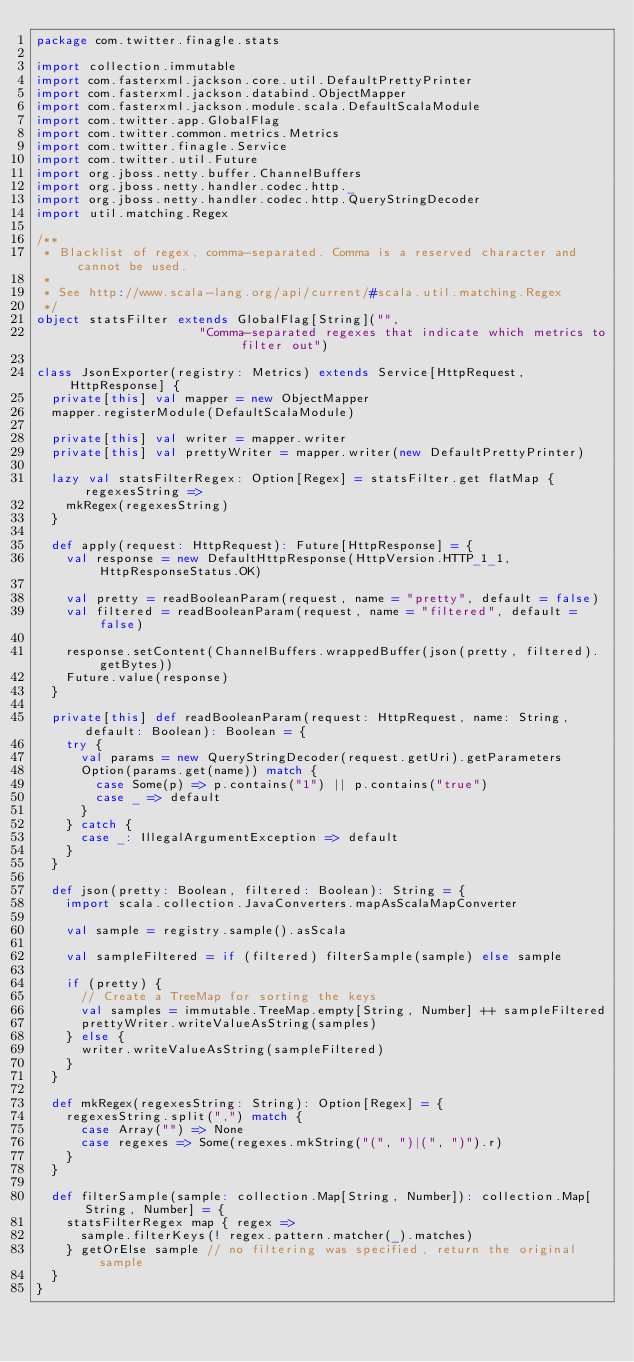Convert code to text. <code><loc_0><loc_0><loc_500><loc_500><_Scala_>package com.twitter.finagle.stats

import collection.immutable
import com.fasterxml.jackson.core.util.DefaultPrettyPrinter
import com.fasterxml.jackson.databind.ObjectMapper
import com.fasterxml.jackson.module.scala.DefaultScalaModule
import com.twitter.app.GlobalFlag
import com.twitter.common.metrics.Metrics
import com.twitter.finagle.Service
import com.twitter.util.Future
import org.jboss.netty.buffer.ChannelBuffers
import org.jboss.netty.handler.codec.http._
import org.jboss.netty.handler.codec.http.QueryStringDecoder
import util.matching.Regex

/**
 * Blacklist of regex, comma-separated. Comma is a reserved character and cannot be used.
 *
 * See http://www.scala-lang.org/api/current/#scala.util.matching.Regex
 */
object statsFilter extends GlobalFlag[String]("",
                      "Comma-separated regexes that indicate which metrics to filter out")

class JsonExporter(registry: Metrics) extends Service[HttpRequest, HttpResponse] {
  private[this] val mapper = new ObjectMapper
  mapper.registerModule(DefaultScalaModule)

  private[this] val writer = mapper.writer
  private[this] val prettyWriter = mapper.writer(new DefaultPrettyPrinter)

  lazy val statsFilterRegex: Option[Regex] = statsFilter.get flatMap { regexesString =>
    mkRegex(regexesString)
  }

  def apply(request: HttpRequest): Future[HttpResponse] = {
    val response = new DefaultHttpResponse(HttpVersion.HTTP_1_1, HttpResponseStatus.OK)

    val pretty = readBooleanParam(request, name = "pretty", default = false)
    val filtered = readBooleanParam(request, name = "filtered", default = false)

    response.setContent(ChannelBuffers.wrappedBuffer(json(pretty, filtered).getBytes))
    Future.value(response)
  }

  private[this] def readBooleanParam(request: HttpRequest, name: String, default: Boolean): Boolean = {
    try {
      val params = new QueryStringDecoder(request.getUri).getParameters
      Option(params.get(name)) match {
        case Some(p) => p.contains("1") || p.contains("true")
        case _ => default
      }
    } catch {
      case _: IllegalArgumentException => default
    }
  }

  def json(pretty: Boolean, filtered: Boolean): String = {
    import scala.collection.JavaConverters.mapAsScalaMapConverter

    val sample = registry.sample().asScala

    val sampleFiltered = if (filtered) filterSample(sample) else sample

    if (pretty) {
      // Create a TreeMap for sorting the keys
      val samples = immutable.TreeMap.empty[String, Number] ++ sampleFiltered
      prettyWriter.writeValueAsString(samples)
    } else {
      writer.writeValueAsString(sampleFiltered)
    }
  }

  def mkRegex(regexesString: String): Option[Regex] = {
    regexesString.split(",") match {
      case Array("") => None
      case regexes => Some(regexes.mkString("(", ")|(", ")").r)
    }
  }

  def filterSample(sample: collection.Map[String, Number]): collection.Map[String, Number] = {
    statsFilterRegex map { regex =>
      sample.filterKeys(! regex.pattern.matcher(_).matches)
    } getOrElse sample // no filtering was specified, return the original sample
  }
}
</code> 